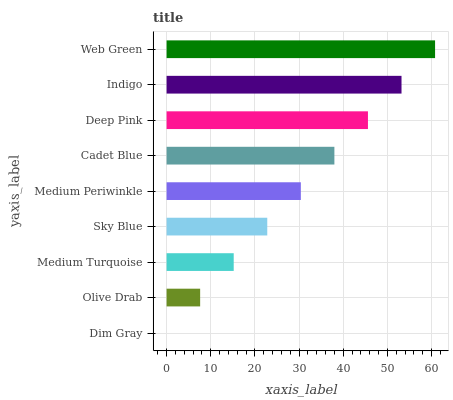Is Dim Gray the minimum?
Answer yes or no. Yes. Is Web Green the maximum?
Answer yes or no. Yes. Is Olive Drab the minimum?
Answer yes or no. No. Is Olive Drab the maximum?
Answer yes or no. No. Is Olive Drab greater than Dim Gray?
Answer yes or no. Yes. Is Dim Gray less than Olive Drab?
Answer yes or no. Yes. Is Dim Gray greater than Olive Drab?
Answer yes or no. No. Is Olive Drab less than Dim Gray?
Answer yes or no. No. Is Medium Periwinkle the high median?
Answer yes or no. Yes. Is Medium Periwinkle the low median?
Answer yes or no. Yes. Is Deep Pink the high median?
Answer yes or no. No. Is Sky Blue the low median?
Answer yes or no. No. 